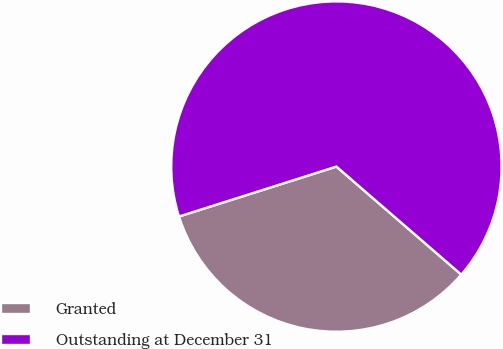Convert chart. <chart><loc_0><loc_0><loc_500><loc_500><pie_chart><fcel>Granted<fcel>Outstanding at December 31<nl><fcel>33.76%<fcel>66.24%<nl></chart> 